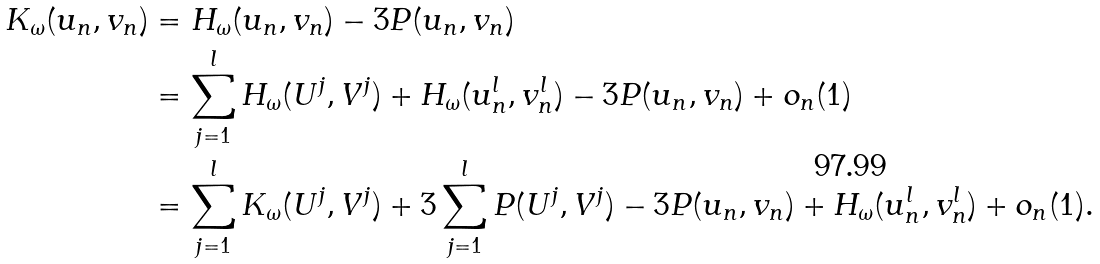<formula> <loc_0><loc_0><loc_500><loc_500>K _ { \omega } ( u _ { n } , v _ { n } ) & = H _ { \omega } ( u _ { n } , v _ { n } ) - 3 P ( u _ { n } , v _ { n } ) \\ & = \sum _ { j = 1 } ^ { l } H _ { \omega } ( U ^ { j } , V ^ { j } ) + H _ { \omega } ( u ^ { l } _ { n } , v ^ { l } _ { n } ) - 3 P ( u _ { n } , v _ { n } ) + o _ { n } ( 1 ) \\ & = \sum _ { j = 1 } ^ { l } K _ { \omega } ( U ^ { j } , V ^ { j } ) + 3 \sum _ { j = 1 } ^ { l } P ( U ^ { j } , V ^ { j } ) - 3 P ( u _ { n } , v _ { n } ) + H _ { \omega } ( u ^ { l } _ { n } , v ^ { l } _ { n } ) + o _ { n } ( 1 ) .</formula> 